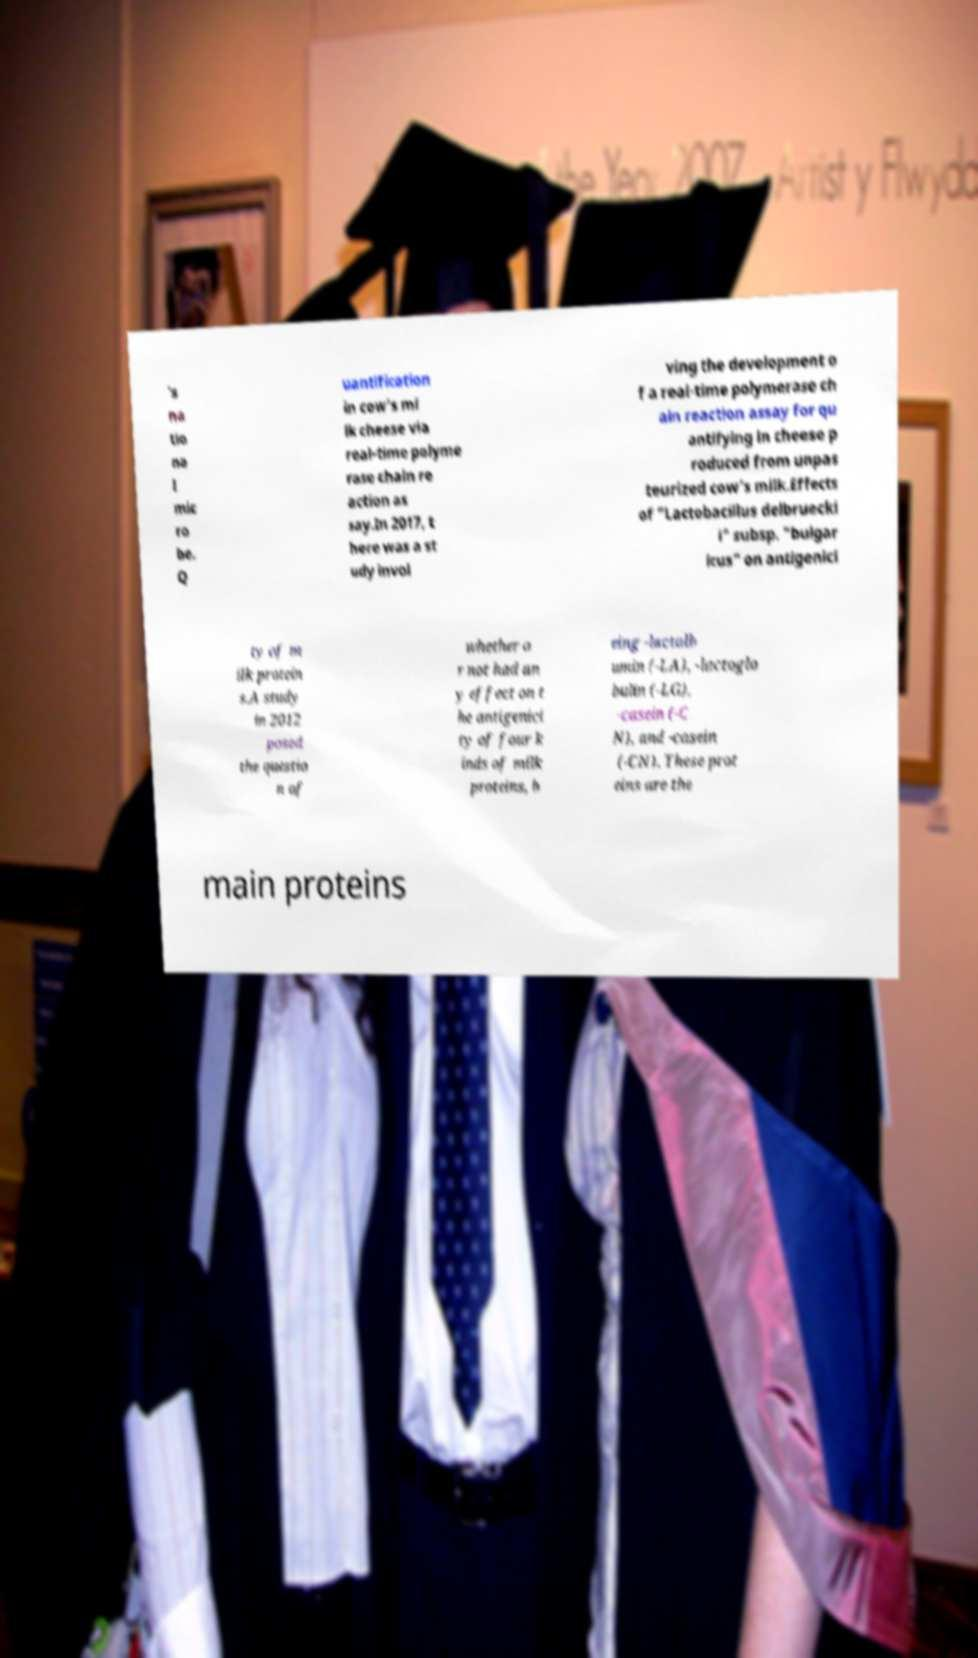Please read and relay the text visible in this image. What does it say? 's na tio na l mic ro be. Q uantification in cow's mi lk cheese via real-time polyme rase chain re action as say.In 2017, t here was a st udy invol ving the development o f a real-time polymerase ch ain reaction assay for qu antifying in cheese p roduced from unpas teurized cow's milk.Effects of "Lactobacillus delbruecki i" subsp. "bulgar icus" on antigenici ty of m ilk protein s.A study in 2012 posed the questio n of whether o r not had an y effect on t he antigenici ty of four k inds of milk proteins, b eing -lactalb umin (-LA), -lactoglo bulin (-LG), -casein (-C N), and -casein (-CN). These prot eins are the main proteins 